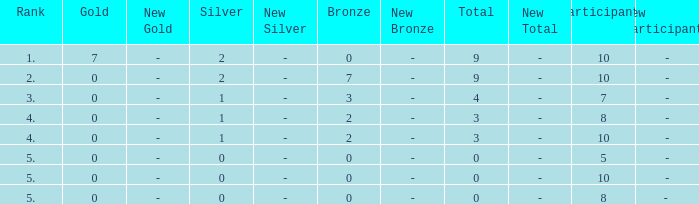What is the total number of Participants that has Silver that's smaller than 0? None. 